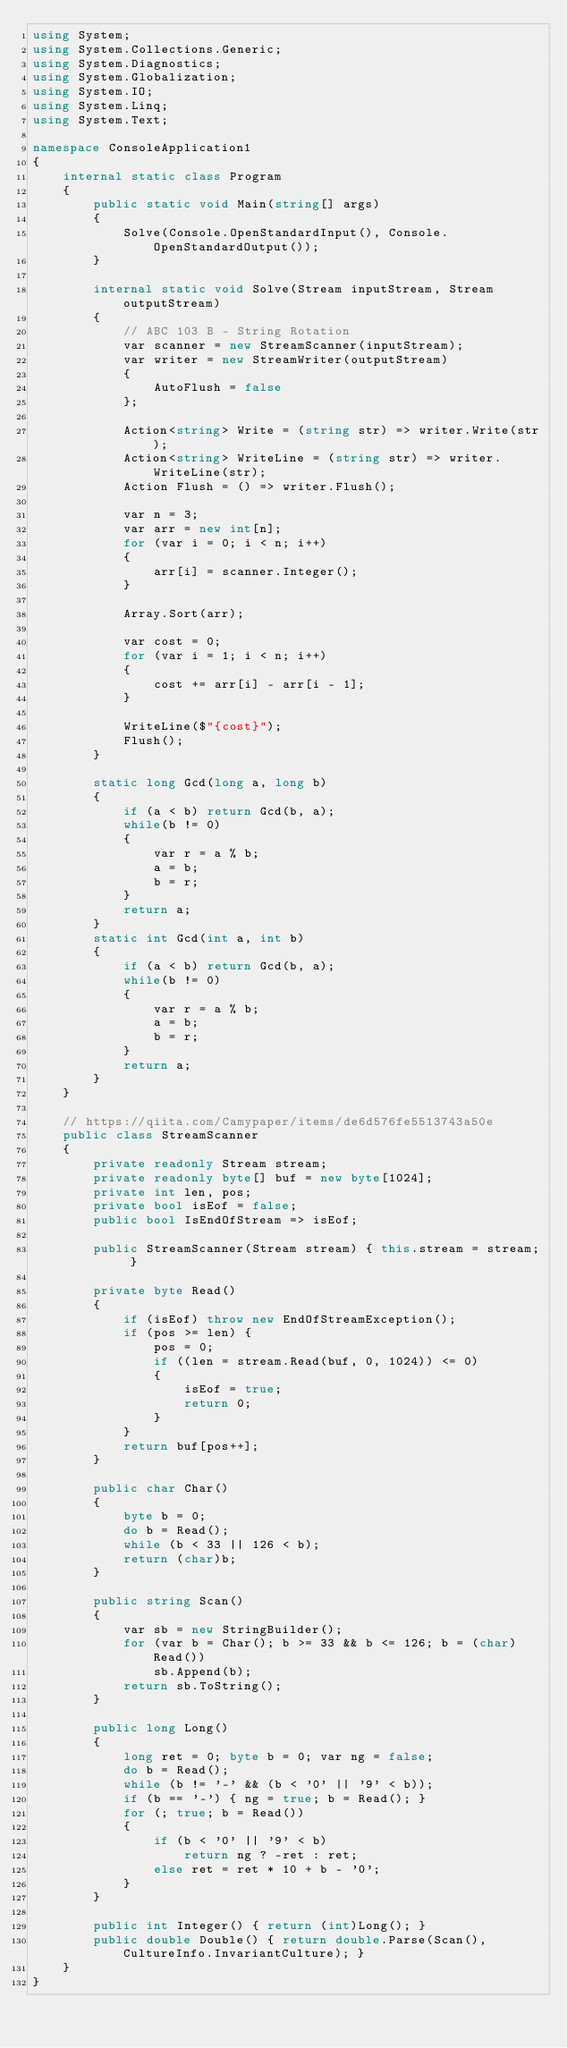<code> <loc_0><loc_0><loc_500><loc_500><_C#_>using System;
using System.Collections.Generic;
using System.Diagnostics;
using System.Globalization;
using System.IO;
using System.Linq;
using System.Text;

namespace ConsoleApplication1
{
    internal static class Program
    {
        public static void Main(string[] args)
        {
            Solve(Console.OpenStandardInput(), Console.OpenStandardOutput());
        }

        internal static void Solve(Stream inputStream, Stream outputStream)
        {
            // ABC 103 B - String Rotation
            var scanner = new StreamScanner(inputStream);
            var writer = new StreamWriter(outputStream)
            {
                AutoFlush = false
            };
            
            Action<string> Write = (string str) => writer.Write(str);
            Action<string> WriteLine = (string str) => writer.WriteLine(str);
            Action Flush = () => writer.Flush();

            var n = 3;
            var arr = new int[n];
            for (var i = 0; i < n; i++)
            {
                arr[i] = scanner.Integer();
            }
            
            Array.Sort(arr);
            
            var cost = 0;
            for (var i = 1; i < n; i++)
            {
                cost += arr[i] - arr[i - 1]; 
            }

            WriteLine($"{cost}");
            Flush();
        }
        
        static long Gcd(long a, long b)
        {
            if (a < b) return Gcd(b, a);
            while(b != 0)
            {
                var r = a % b;
                a = b;
                b = r;
            }
            return a;
        }
        static int Gcd(int a, int b)
        {
            if (a < b) return Gcd(b, a);
            while(b != 0)
            {
                var r = a % b;
                a = b;
                b = r;
            }
            return a;
        }
    }
    
    // https://qiita.com/Camypaper/items/de6d576fe5513743a50e
    public class StreamScanner
    {   
        private readonly Stream stream;
        private readonly byte[] buf = new byte[1024];
        private int len, pos;
        private bool isEof = false;
        public bool IsEndOfStream => isEof;

        public StreamScanner(Stream stream) { this.stream = stream; }
        
        private byte Read()
        {
            if (isEof) throw new EndOfStreamException();
            if (pos >= len) {
                pos = 0;
                if ((len = stream.Read(buf, 0, 1024)) <= 0)
                {
                    isEof = true;
                    return 0;
                }
            }
            return buf[pos++];
        }
        
        public char Char() 
        {
            byte b = 0;
            do b = Read();
            while (b < 33 || 126 < b);
            return (char)b; 
        }
        
        public string Scan()
        {
            var sb = new StringBuilder();
            for (var b = Char(); b >= 33 && b <= 126; b = (char)Read())
                sb.Append(b);
            return sb.ToString();
        }
        
        public long Long()
        {
            long ret = 0; byte b = 0; var ng = false;
            do b = Read();
            while (b != '-' && (b < '0' || '9' < b));
            if (b == '-') { ng = true; b = Read(); }
            for (; true; b = Read())
            {
                if (b < '0' || '9' < b)
                    return ng ? -ret : ret;
                else ret = ret * 10 + b - '0';
            }
        }
        
        public int Integer() { return (int)Long(); }
        public double Double() { return double.Parse(Scan(), CultureInfo.InvariantCulture); }
    }
}
</code> 